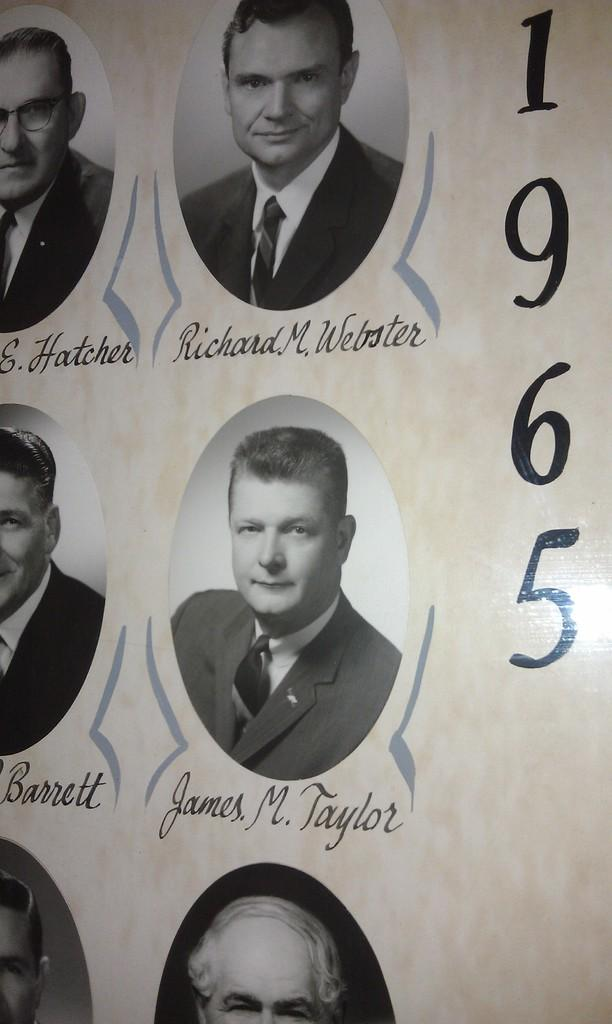What is depicted in the image? There are photos of people in the image. Can you describe any additional information provided with the photos? The names of the people are present with their respective photos. What else can be seen in the image? There are numbers on a paper in the image. What type of advice can be seen written on the ball in the image? There is no ball present in the image, so it is not possible to determine what advice might be written on it. 